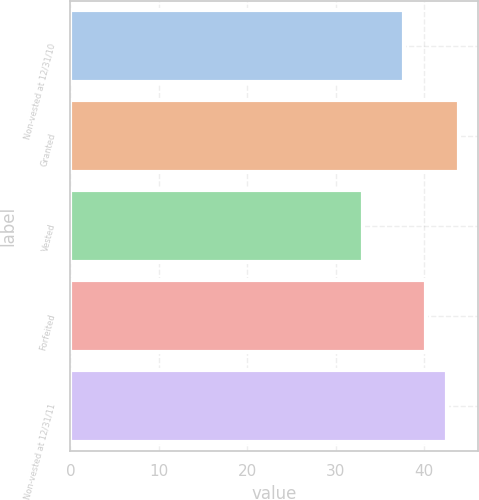Convert chart to OTSL. <chart><loc_0><loc_0><loc_500><loc_500><bar_chart><fcel>Non-vested at 12/31/10<fcel>Granted<fcel>Vested<fcel>Forfeited<fcel>Non-vested at 12/31/11<nl><fcel>37.76<fcel>43.92<fcel>33.07<fcel>40.2<fcel>42.54<nl></chart> 